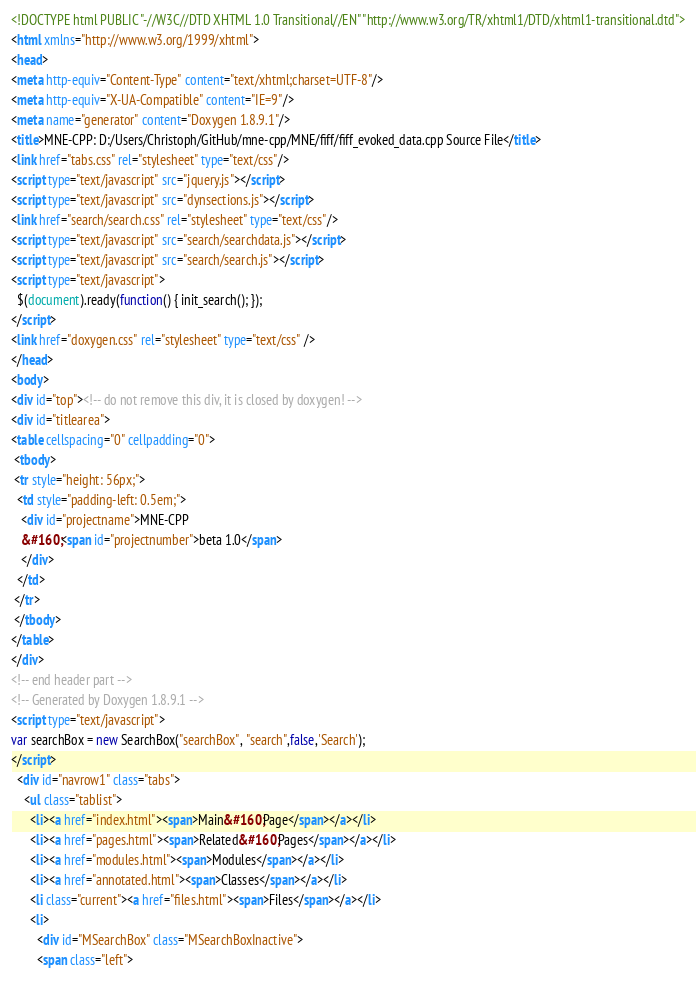<code> <loc_0><loc_0><loc_500><loc_500><_HTML_><!DOCTYPE html PUBLIC "-//W3C//DTD XHTML 1.0 Transitional//EN" "http://www.w3.org/TR/xhtml1/DTD/xhtml1-transitional.dtd">
<html xmlns="http://www.w3.org/1999/xhtml">
<head>
<meta http-equiv="Content-Type" content="text/xhtml;charset=UTF-8"/>
<meta http-equiv="X-UA-Compatible" content="IE=9"/>
<meta name="generator" content="Doxygen 1.8.9.1"/>
<title>MNE-CPP: D:/Users/Christoph/GitHub/mne-cpp/MNE/fiff/fiff_evoked_data.cpp Source File</title>
<link href="tabs.css" rel="stylesheet" type="text/css"/>
<script type="text/javascript" src="jquery.js"></script>
<script type="text/javascript" src="dynsections.js"></script>
<link href="search/search.css" rel="stylesheet" type="text/css"/>
<script type="text/javascript" src="search/searchdata.js"></script>
<script type="text/javascript" src="search/search.js"></script>
<script type="text/javascript">
  $(document).ready(function() { init_search(); });
</script>
<link href="doxygen.css" rel="stylesheet" type="text/css" />
</head>
<body>
<div id="top"><!-- do not remove this div, it is closed by doxygen! -->
<div id="titlearea">
<table cellspacing="0" cellpadding="0">
 <tbody>
 <tr style="height: 56px;">
  <td style="padding-left: 0.5em;">
   <div id="projectname">MNE-CPP
   &#160;<span id="projectnumber">beta 1.0</span>
   </div>
  </td>
 </tr>
 </tbody>
</table>
</div>
<!-- end header part -->
<!-- Generated by Doxygen 1.8.9.1 -->
<script type="text/javascript">
var searchBox = new SearchBox("searchBox", "search",false,'Search');
</script>
  <div id="navrow1" class="tabs">
    <ul class="tablist">
      <li><a href="index.html"><span>Main&#160;Page</span></a></li>
      <li><a href="pages.html"><span>Related&#160;Pages</span></a></li>
      <li><a href="modules.html"><span>Modules</span></a></li>
      <li><a href="annotated.html"><span>Classes</span></a></li>
      <li class="current"><a href="files.html"><span>Files</span></a></li>
      <li>
        <div id="MSearchBox" class="MSearchBoxInactive">
        <span class="left"></code> 